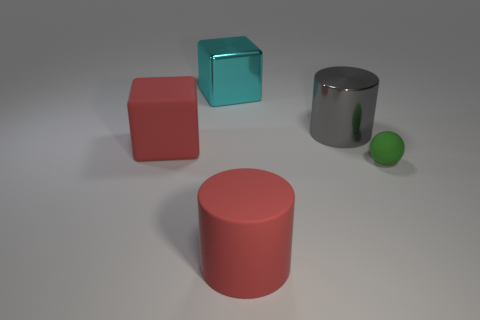Add 4 big balls. How many objects exist? 9 Subtract all cubes. How many objects are left? 3 Add 5 rubber blocks. How many rubber blocks exist? 6 Subtract 1 cyan blocks. How many objects are left? 4 Subtract all green matte objects. Subtract all red rubber cylinders. How many objects are left? 3 Add 3 small green objects. How many small green objects are left? 4 